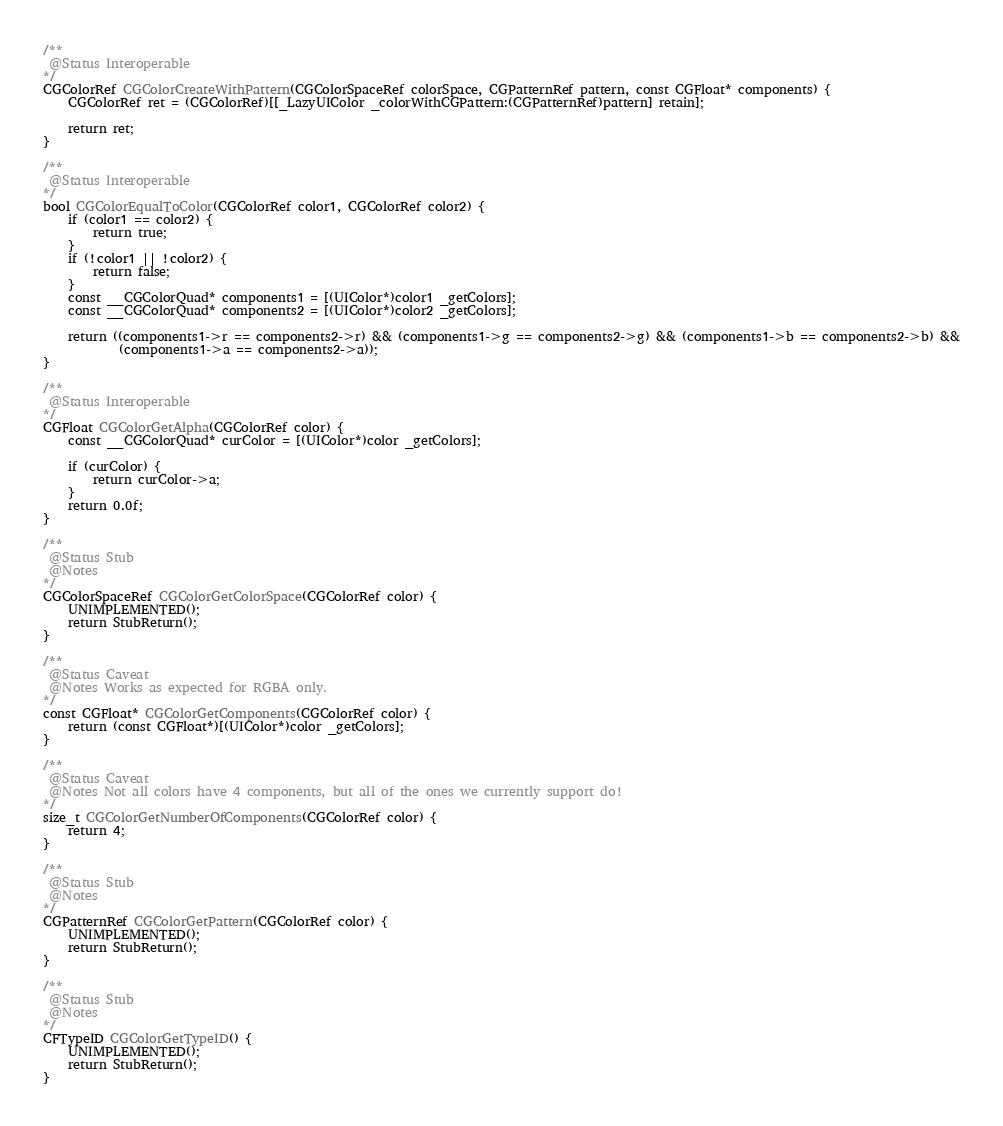<code> <loc_0><loc_0><loc_500><loc_500><_ObjectiveC_>/**
 @Status Interoperable
*/
CGColorRef CGColorCreateWithPattern(CGColorSpaceRef colorSpace, CGPatternRef pattern, const CGFloat* components) {
    CGColorRef ret = (CGColorRef)[[_LazyUIColor _colorWithCGPattern:(CGPatternRef)pattern] retain];

    return ret;
}

/**
 @Status Interoperable
*/
bool CGColorEqualToColor(CGColorRef color1, CGColorRef color2) {
    if (color1 == color2) {
        return true;
    }
    if (!color1 || !color2) {
        return false;
    }
    const __CGColorQuad* components1 = [(UIColor*)color1 _getColors];
    const __CGColorQuad* components2 = [(UIColor*)color2 _getColors];

    return ((components1->r == components2->r) && (components1->g == components2->g) && (components1->b == components2->b) &&
            (components1->a == components2->a));
}

/**
 @Status Interoperable
*/
CGFloat CGColorGetAlpha(CGColorRef color) {
    const __CGColorQuad* curColor = [(UIColor*)color _getColors];

    if (curColor) {
        return curColor->a;
    }
    return 0.0f;
}

/**
 @Status Stub
 @Notes
*/
CGColorSpaceRef CGColorGetColorSpace(CGColorRef color) {
    UNIMPLEMENTED();
    return StubReturn();
}

/**
 @Status Caveat
 @Notes Works as expected for RGBA only.
*/
const CGFloat* CGColorGetComponents(CGColorRef color) {
    return (const CGFloat*)[(UIColor*)color _getColors];
}

/**
 @Status Caveat
 @Notes Not all colors have 4 components, but all of the ones we currently support do!
*/
size_t CGColorGetNumberOfComponents(CGColorRef color) {
    return 4;
}

/**
 @Status Stub
 @Notes
*/
CGPatternRef CGColorGetPattern(CGColorRef color) {
    UNIMPLEMENTED();
    return StubReturn();
}

/**
 @Status Stub
 @Notes
*/
CFTypeID CGColorGetTypeID() {
    UNIMPLEMENTED();
    return StubReturn();
}
</code> 